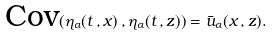<formula> <loc_0><loc_0><loc_500><loc_500>\text {Cov} ( \eta _ { \alpha } ( t \, , x ) \, , \eta _ { \alpha } ( t \, , z ) ) = \bar { u } _ { \alpha } ( x \, , z ) .</formula> 